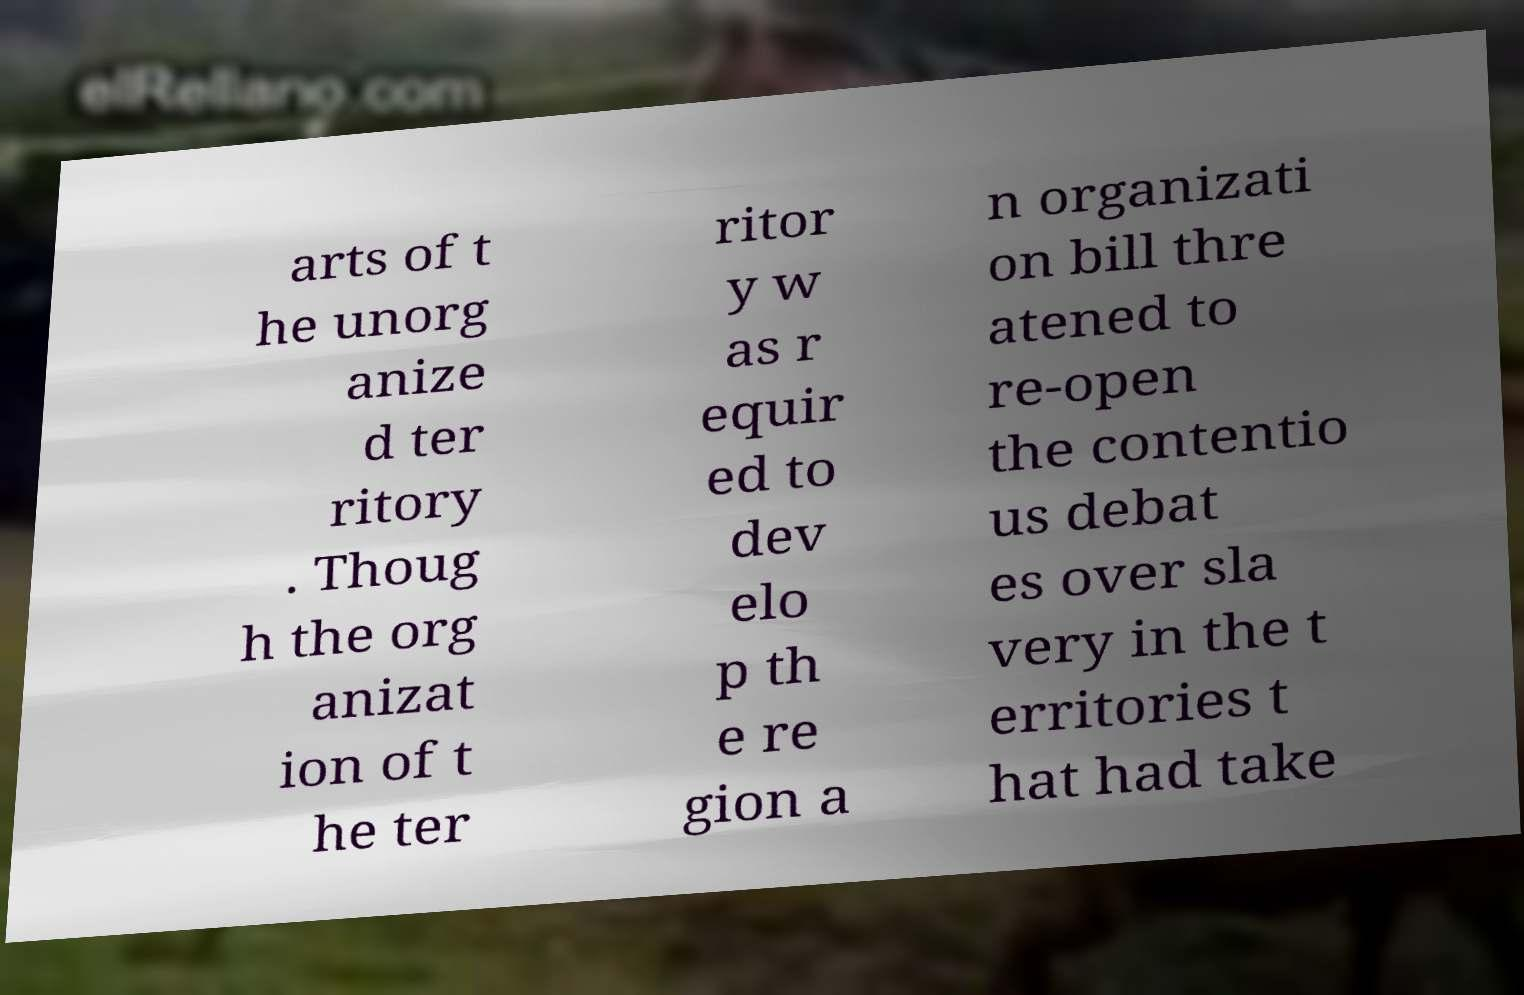Please identify and transcribe the text found in this image. arts of t he unorg anize d ter ritory . Thoug h the org anizat ion of t he ter ritor y w as r equir ed to dev elo p th e re gion a n organizati on bill thre atened to re-open the contentio us debat es over sla very in the t erritories t hat had take 